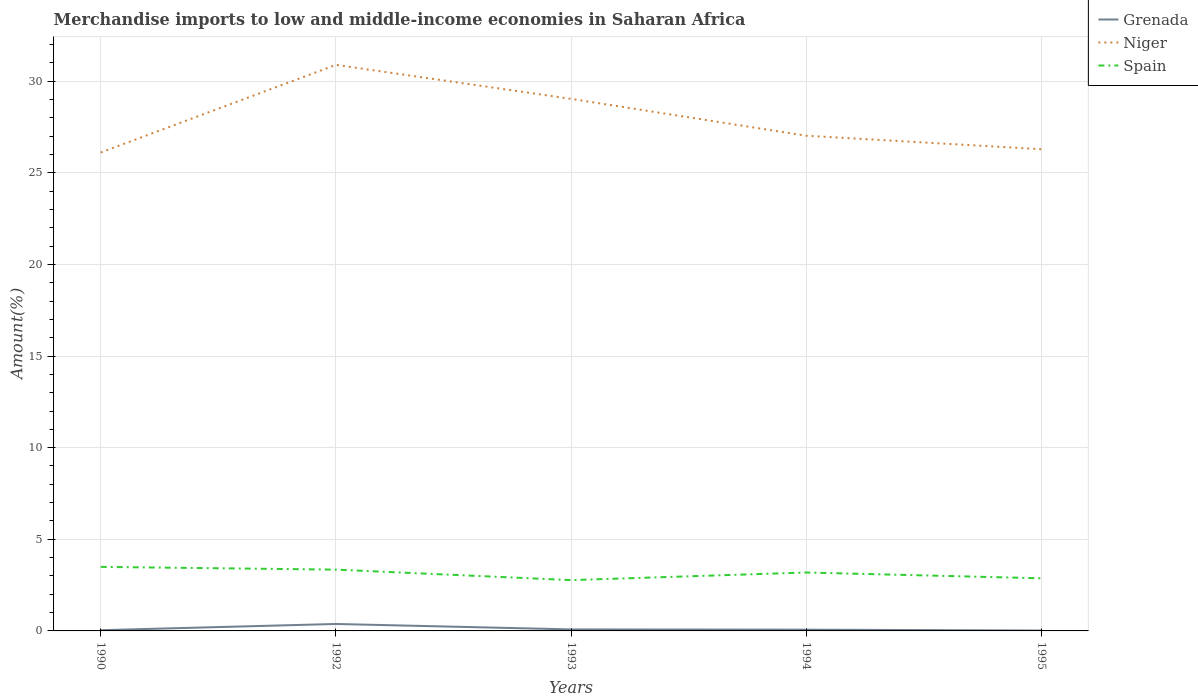Does the line corresponding to Niger intersect with the line corresponding to Spain?
Keep it short and to the point. No. Is the number of lines equal to the number of legend labels?
Offer a terse response. Yes. Across all years, what is the maximum percentage of amount earned from merchandise imports in Grenada?
Your answer should be compact. 0.02. In which year was the percentage of amount earned from merchandise imports in Grenada maximum?
Your answer should be very brief. 1995. What is the total percentage of amount earned from merchandise imports in Niger in the graph?
Offer a terse response. -4.78. What is the difference between the highest and the second highest percentage of amount earned from merchandise imports in Niger?
Ensure brevity in your answer.  4.78. What is the difference between two consecutive major ticks on the Y-axis?
Give a very brief answer. 5. Does the graph contain any zero values?
Your answer should be compact. No. Where does the legend appear in the graph?
Provide a succinct answer. Top right. How many legend labels are there?
Your answer should be compact. 3. What is the title of the graph?
Provide a short and direct response. Merchandise imports to low and middle-income economies in Saharan Africa. What is the label or title of the X-axis?
Keep it short and to the point. Years. What is the label or title of the Y-axis?
Give a very brief answer. Amount(%). What is the Amount(%) in Grenada in 1990?
Your response must be concise. 0.04. What is the Amount(%) in Niger in 1990?
Offer a very short reply. 26.11. What is the Amount(%) in Spain in 1990?
Give a very brief answer. 3.49. What is the Amount(%) in Grenada in 1992?
Make the answer very short. 0.38. What is the Amount(%) of Niger in 1992?
Give a very brief answer. 30.89. What is the Amount(%) in Spain in 1992?
Your response must be concise. 3.34. What is the Amount(%) in Grenada in 1993?
Your answer should be compact. 0.08. What is the Amount(%) of Niger in 1993?
Ensure brevity in your answer.  29.03. What is the Amount(%) of Spain in 1993?
Make the answer very short. 2.77. What is the Amount(%) of Grenada in 1994?
Your response must be concise. 0.07. What is the Amount(%) of Niger in 1994?
Your answer should be compact. 27.02. What is the Amount(%) in Spain in 1994?
Give a very brief answer. 3.19. What is the Amount(%) in Grenada in 1995?
Make the answer very short. 0.02. What is the Amount(%) of Niger in 1995?
Keep it short and to the point. 26.29. What is the Amount(%) of Spain in 1995?
Provide a short and direct response. 2.87. Across all years, what is the maximum Amount(%) in Grenada?
Provide a short and direct response. 0.38. Across all years, what is the maximum Amount(%) of Niger?
Offer a terse response. 30.89. Across all years, what is the maximum Amount(%) of Spain?
Make the answer very short. 3.49. Across all years, what is the minimum Amount(%) of Grenada?
Keep it short and to the point. 0.02. Across all years, what is the minimum Amount(%) of Niger?
Provide a short and direct response. 26.11. Across all years, what is the minimum Amount(%) of Spain?
Offer a terse response. 2.77. What is the total Amount(%) in Grenada in the graph?
Provide a succinct answer. 0.59. What is the total Amount(%) of Niger in the graph?
Give a very brief answer. 139.34. What is the total Amount(%) of Spain in the graph?
Provide a succinct answer. 15.67. What is the difference between the Amount(%) in Grenada in 1990 and that in 1992?
Your answer should be very brief. -0.34. What is the difference between the Amount(%) of Niger in 1990 and that in 1992?
Your response must be concise. -4.78. What is the difference between the Amount(%) in Spain in 1990 and that in 1992?
Offer a terse response. 0.15. What is the difference between the Amount(%) of Grenada in 1990 and that in 1993?
Your response must be concise. -0.04. What is the difference between the Amount(%) in Niger in 1990 and that in 1993?
Give a very brief answer. -2.93. What is the difference between the Amount(%) of Spain in 1990 and that in 1993?
Keep it short and to the point. 0.72. What is the difference between the Amount(%) in Grenada in 1990 and that in 1994?
Offer a very short reply. -0.03. What is the difference between the Amount(%) of Niger in 1990 and that in 1994?
Provide a succinct answer. -0.92. What is the difference between the Amount(%) in Spain in 1990 and that in 1994?
Provide a succinct answer. 0.31. What is the difference between the Amount(%) in Grenada in 1990 and that in 1995?
Offer a very short reply. 0.02. What is the difference between the Amount(%) of Niger in 1990 and that in 1995?
Provide a short and direct response. -0.18. What is the difference between the Amount(%) of Spain in 1990 and that in 1995?
Your answer should be very brief. 0.62. What is the difference between the Amount(%) of Grenada in 1992 and that in 1993?
Ensure brevity in your answer.  0.3. What is the difference between the Amount(%) in Niger in 1992 and that in 1993?
Offer a very short reply. 1.85. What is the difference between the Amount(%) of Spain in 1992 and that in 1993?
Give a very brief answer. 0.57. What is the difference between the Amount(%) of Grenada in 1992 and that in 1994?
Offer a terse response. 0.31. What is the difference between the Amount(%) of Niger in 1992 and that in 1994?
Make the answer very short. 3.87. What is the difference between the Amount(%) of Spain in 1992 and that in 1994?
Offer a very short reply. 0.16. What is the difference between the Amount(%) in Grenada in 1992 and that in 1995?
Offer a very short reply. 0.36. What is the difference between the Amount(%) in Niger in 1992 and that in 1995?
Offer a terse response. 4.6. What is the difference between the Amount(%) of Spain in 1992 and that in 1995?
Provide a succinct answer. 0.47. What is the difference between the Amount(%) of Grenada in 1993 and that in 1994?
Provide a short and direct response. 0.01. What is the difference between the Amount(%) of Niger in 1993 and that in 1994?
Make the answer very short. 2.01. What is the difference between the Amount(%) in Spain in 1993 and that in 1994?
Your answer should be very brief. -0.42. What is the difference between the Amount(%) in Grenada in 1993 and that in 1995?
Ensure brevity in your answer.  0.06. What is the difference between the Amount(%) in Niger in 1993 and that in 1995?
Give a very brief answer. 2.75. What is the difference between the Amount(%) of Spain in 1993 and that in 1995?
Your response must be concise. -0.1. What is the difference between the Amount(%) of Grenada in 1994 and that in 1995?
Your answer should be compact. 0.05. What is the difference between the Amount(%) in Niger in 1994 and that in 1995?
Provide a short and direct response. 0.74. What is the difference between the Amount(%) of Spain in 1994 and that in 1995?
Provide a succinct answer. 0.32. What is the difference between the Amount(%) of Grenada in 1990 and the Amount(%) of Niger in 1992?
Offer a terse response. -30.85. What is the difference between the Amount(%) of Grenada in 1990 and the Amount(%) of Spain in 1992?
Provide a succinct answer. -3.3. What is the difference between the Amount(%) in Niger in 1990 and the Amount(%) in Spain in 1992?
Provide a short and direct response. 22.76. What is the difference between the Amount(%) of Grenada in 1990 and the Amount(%) of Niger in 1993?
Your answer should be very brief. -28.99. What is the difference between the Amount(%) in Grenada in 1990 and the Amount(%) in Spain in 1993?
Give a very brief answer. -2.73. What is the difference between the Amount(%) of Niger in 1990 and the Amount(%) of Spain in 1993?
Ensure brevity in your answer.  23.33. What is the difference between the Amount(%) in Grenada in 1990 and the Amount(%) in Niger in 1994?
Ensure brevity in your answer.  -26.98. What is the difference between the Amount(%) of Grenada in 1990 and the Amount(%) of Spain in 1994?
Provide a short and direct response. -3.15. What is the difference between the Amount(%) of Niger in 1990 and the Amount(%) of Spain in 1994?
Your answer should be very brief. 22.92. What is the difference between the Amount(%) of Grenada in 1990 and the Amount(%) of Niger in 1995?
Your answer should be compact. -26.25. What is the difference between the Amount(%) of Grenada in 1990 and the Amount(%) of Spain in 1995?
Provide a succinct answer. -2.83. What is the difference between the Amount(%) of Niger in 1990 and the Amount(%) of Spain in 1995?
Your answer should be compact. 23.23. What is the difference between the Amount(%) in Grenada in 1992 and the Amount(%) in Niger in 1993?
Provide a short and direct response. -28.65. What is the difference between the Amount(%) of Grenada in 1992 and the Amount(%) of Spain in 1993?
Give a very brief answer. -2.39. What is the difference between the Amount(%) of Niger in 1992 and the Amount(%) of Spain in 1993?
Make the answer very short. 28.12. What is the difference between the Amount(%) of Grenada in 1992 and the Amount(%) of Niger in 1994?
Offer a terse response. -26.64. What is the difference between the Amount(%) of Grenada in 1992 and the Amount(%) of Spain in 1994?
Your answer should be compact. -2.81. What is the difference between the Amount(%) in Niger in 1992 and the Amount(%) in Spain in 1994?
Provide a succinct answer. 27.7. What is the difference between the Amount(%) of Grenada in 1992 and the Amount(%) of Niger in 1995?
Your answer should be very brief. -25.91. What is the difference between the Amount(%) in Grenada in 1992 and the Amount(%) in Spain in 1995?
Ensure brevity in your answer.  -2.49. What is the difference between the Amount(%) in Niger in 1992 and the Amount(%) in Spain in 1995?
Make the answer very short. 28.02. What is the difference between the Amount(%) of Grenada in 1993 and the Amount(%) of Niger in 1994?
Your answer should be compact. -26.94. What is the difference between the Amount(%) in Grenada in 1993 and the Amount(%) in Spain in 1994?
Make the answer very short. -3.1. What is the difference between the Amount(%) in Niger in 1993 and the Amount(%) in Spain in 1994?
Keep it short and to the point. 25.85. What is the difference between the Amount(%) of Grenada in 1993 and the Amount(%) of Niger in 1995?
Ensure brevity in your answer.  -26.2. What is the difference between the Amount(%) in Grenada in 1993 and the Amount(%) in Spain in 1995?
Make the answer very short. -2.79. What is the difference between the Amount(%) in Niger in 1993 and the Amount(%) in Spain in 1995?
Give a very brief answer. 26.16. What is the difference between the Amount(%) of Grenada in 1994 and the Amount(%) of Niger in 1995?
Your answer should be very brief. -26.22. What is the difference between the Amount(%) of Grenada in 1994 and the Amount(%) of Spain in 1995?
Give a very brief answer. -2.8. What is the difference between the Amount(%) in Niger in 1994 and the Amount(%) in Spain in 1995?
Your response must be concise. 24.15. What is the average Amount(%) in Grenada per year?
Ensure brevity in your answer.  0.12. What is the average Amount(%) in Niger per year?
Provide a short and direct response. 27.87. What is the average Amount(%) of Spain per year?
Provide a short and direct response. 3.13. In the year 1990, what is the difference between the Amount(%) of Grenada and Amount(%) of Niger?
Offer a very short reply. -26.07. In the year 1990, what is the difference between the Amount(%) of Grenada and Amount(%) of Spain?
Keep it short and to the point. -3.45. In the year 1990, what is the difference between the Amount(%) of Niger and Amount(%) of Spain?
Provide a succinct answer. 22.61. In the year 1992, what is the difference between the Amount(%) of Grenada and Amount(%) of Niger?
Ensure brevity in your answer.  -30.51. In the year 1992, what is the difference between the Amount(%) in Grenada and Amount(%) in Spain?
Give a very brief answer. -2.97. In the year 1992, what is the difference between the Amount(%) of Niger and Amount(%) of Spain?
Provide a succinct answer. 27.54. In the year 1993, what is the difference between the Amount(%) of Grenada and Amount(%) of Niger?
Provide a short and direct response. -28.95. In the year 1993, what is the difference between the Amount(%) in Grenada and Amount(%) in Spain?
Ensure brevity in your answer.  -2.69. In the year 1993, what is the difference between the Amount(%) in Niger and Amount(%) in Spain?
Keep it short and to the point. 26.26. In the year 1994, what is the difference between the Amount(%) of Grenada and Amount(%) of Niger?
Keep it short and to the point. -26.95. In the year 1994, what is the difference between the Amount(%) in Grenada and Amount(%) in Spain?
Give a very brief answer. -3.12. In the year 1994, what is the difference between the Amount(%) of Niger and Amount(%) of Spain?
Your response must be concise. 23.83. In the year 1995, what is the difference between the Amount(%) in Grenada and Amount(%) in Niger?
Your response must be concise. -26.26. In the year 1995, what is the difference between the Amount(%) in Grenada and Amount(%) in Spain?
Provide a succinct answer. -2.85. In the year 1995, what is the difference between the Amount(%) in Niger and Amount(%) in Spain?
Your answer should be very brief. 23.41. What is the ratio of the Amount(%) in Grenada in 1990 to that in 1992?
Provide a short and direct response. 0.11. What is the ratio of the Amount(%) in Niger in 1990 to that in 1992?
Your response must be concise. 0.85. What is the ratio of the Amount(%) in Spain in 1990 to that in 1992?
Make the answer very short. 1.04. What is the ratio of the Amount(%) in Grenada in 1990 to that in 1993?
Keep it short and to the point. 0.48. What is the ratio of the Amount(%) of Niger in 1990 to that in 1993?
Offer a terse response. 0.9. What is the ratio of the Amount(%) of Spain in 1990 to that in 1993?
Keep it short and to the point. 1.26. What is the ratio of the Amount(%) in Grenada in 1990 to that in 1994?
Your answer should be compact. 0.58. What is the ratio of the Amount(%) in Niger in 1990 to that in 1994?
Give a very brief answer. 0.97. What is the ratio of the Amount(%) of Spain in 1990 to that in 1994?
Ensure brevity in your answer.  1.1. What is the ratio of the Amount(%) of Grenada in 1990 to that in 1995?
Give a very brief answer. 1.83. What is the ratio of the Amount(%) in Spain in 1990 to that in 1995?
Your response must be concise. 1.22. What is the ratio of the Amount(%) in Grenada in 1992 to that in 1993?
Ensure brevity in your answer.  4.58. What is the ratio of the Amount(%) of Niger in 1992 to that in 1993?
Offer a very short reply. 1.06. What is the ratio of the Amount(%) of Spain in 1992 to that in 1993?
Your answer should be compact. 1.21. What is the ratio of the Amount(%) in Grenada in 1992 to that in 1994?
Your answer should be very brief. 5.51. What is the ratio of the Amount(%) in Niger in 1992 to that in 1994?
Your response must be concise. 1.14. What is the ratio of the Amount(%) in Spain in 1992 to that in 1994?
Your response must be concise. 1.05. What is the ratio of the Amount(%) in Grenada in 1992 to that in 1995?
Offer a very short reply. 17.35. What is the ratio of the Amount(%) of Niger in 1992 to that in 1995?
Ensure brevity in your answer.  1.18. What is the ratio of the Amount(%) in Spain in 1992 to that in 1995?
Offer a very short reply. 1.16. What is the ratio of the Amount(%) of Grenada in 1993 to that in 1994?
Your response must be concise. 1.2. What is the ratio of the Amount(%) in Niger in 1993 to that in 1994?
Offer a very short reply. 1.07. What is the ratio of the Amount(%) in Spain in 1993 to that in 1994?
Offer a terse response. 0.87. What is the ratio of the Amount(%) in Grenada in 1993 to that in 1995?
Your answer should be compact. 3.79. What is the ratio of the Amount(%) of Niger in 1993 to that in 1995?
Provide a short and direct response. 1.1. What is the ratio of the Amount(%) of Spain in 1993 to that in 1995?
Give a very brief answer. 0.97. What is the ratio of the Amount(%) of Grenada in 1994 to that in 1995?
Your answer should be compact. 3.15. What is the ratio of the Amount(%) in Niger in 1994 to that in 1995?
Your response must be concise. 1.03. What is the ratio of the Amount(%) of Spain in 1994 to that in 1995?
Your answer should be very brief. 1.11. What is the difference between the highest and the second highest Amount(%) of Grenada?
Your answer should be very brief. 0.3. What is the difference between the highest and the second highest Amount(%) in Niger?
Provide a short and direct response. 1.85. What is the difference between the highest and the second highest Amount(%) of Spain?
Provide a short and direct response. 0.15. What is the difference between the highest and the lowest Amount(%) in Grenada?
Give a very brief answer. 0.36. What is the difference between the highest and the lowest Amount(%) of Niger?
Offer a terse response. 4.78. What is the difference between the highest and the lowest Amount(%) of Spain?
Offer a very short reply. 0.72. 